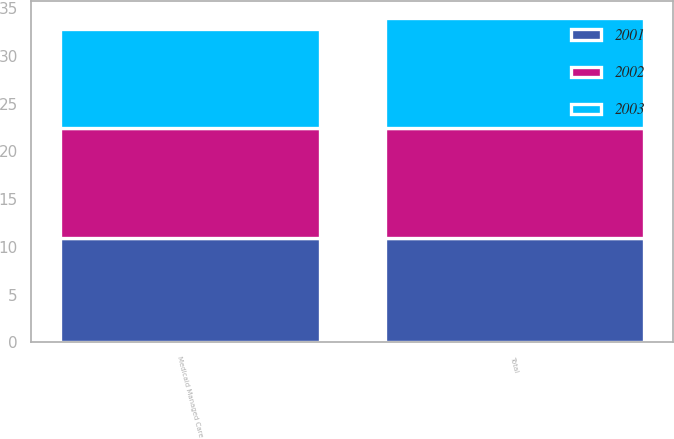<chart> <loc_0><loc_0><loc_500><loc_500><stacked_bar_chart><ecel><fcel>Medicaid Managed Care<fcel>Total<nl><fcel>2003<fcel>10.3<fcel>11.5<nl><fcel>2001<fcel>10.9<fcel>10.9<nl><fcel>2002<fcel>11.6<fcel>11.6<nl></chart> 